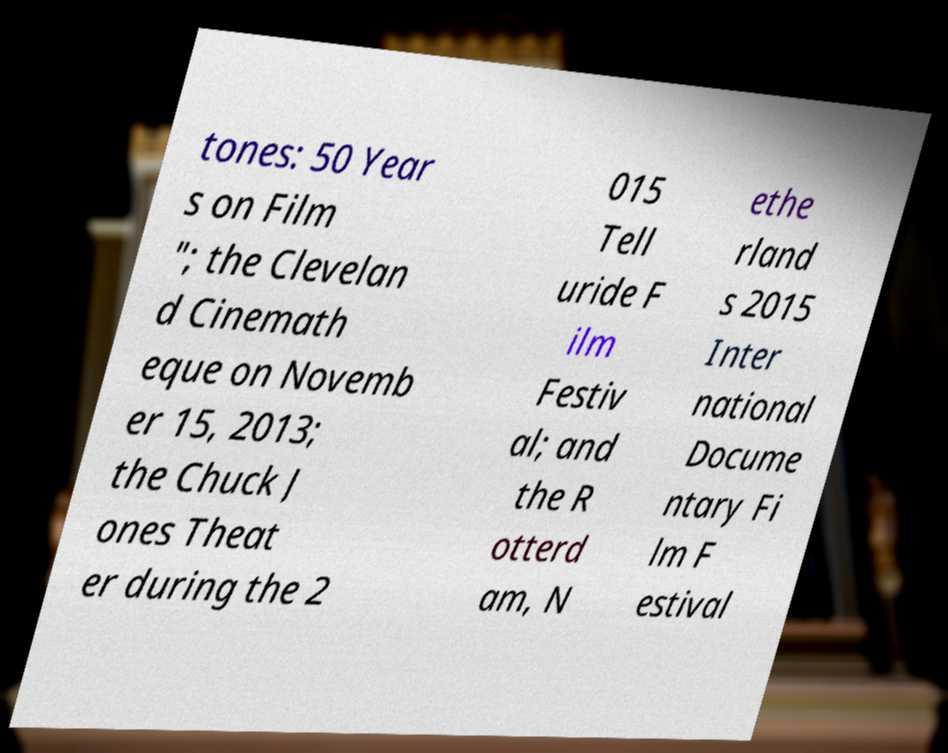What messages or text are displayed in this image? I need them in a readable, typed format. tones: 50 Year s on Film "; the Clevelan d Cinemath eque on Novemb er 15, 2013; the Chuck J ones Theat er during the 2 015 Tell uride F ilm Festiv al; and the R otterd am, N ethe rland s 2015 Inter national Docume ntary Fi lm F estival 